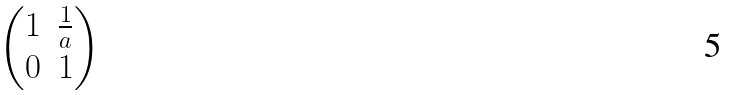<formula> <loc_0><loc_0><loc_500><loc_500>\begin{pmatrix} 1 & \frac { 1 } { a } \\ 0 & 1 \end{pmatrix}</formula> 